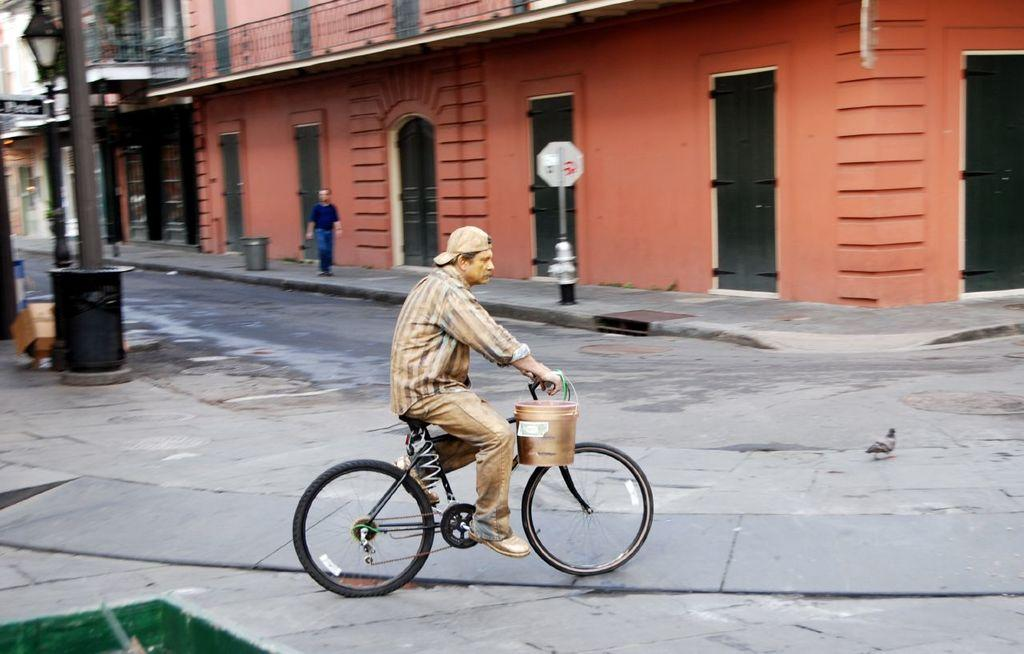What is the man in the image doing? The man is riding a bicycle in the image. What is the man carrying on the bicycle? The man has a bucket on the bicycle. What can be seen in the background of the image? There is a building and a pigeon on the road in the background of the image. What type of vessel is the man using to transport frogs in the image? There is no vessel or frogs present in the image. What is the man doing to clear his throat in the image? There is no indication of the man clearing his throat in the image. 